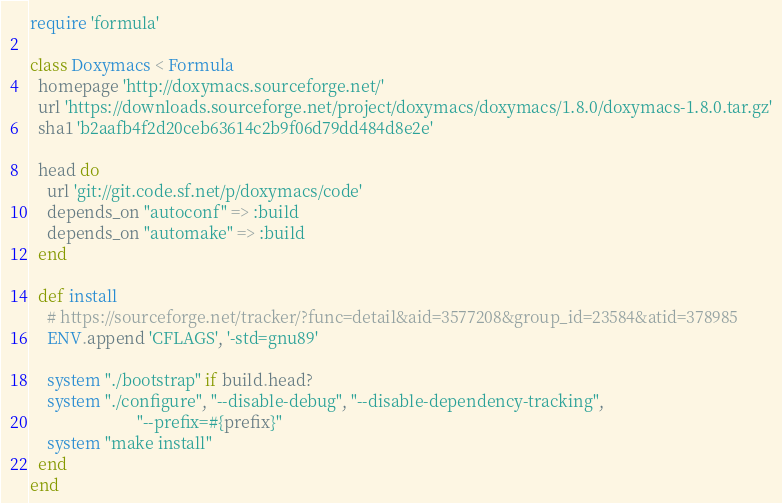<code> <loc_0><loc_0><loc_500><loc_500><_Ruby_>require 'formula'

class Doxymacs < Formula
  homepage 'http://doxymacs.sourceforge.net/'
  url 'https://downloads.sourceforge.net/project/doxymacs/doxymacs/1.8.0/doxymacs-1.8.0.tar.gz'
  sha1 'b2aafb4f2d20ceb63614c2b9f06d79dd484d8e2e'

  head do
    url 'git://git.code.sf.net/p/doxymacs/code'
    depends_on "autoconf" => :build
    depends_on "automake" => :build
  end

  def install
    # https://sourceforge.net/tracker/?func=detail&aid=3577208&group_id=23584&atid=378985
    ENV.append 'CFLAGS', '-std=gnu89'

    system "./bootstrap" if build.head?
    system "./configure", "--disable-debug", "--disable-dependency-tracking",
                          "--prefix=#{prefix}"
    system "make install"
  end
end
</code> 